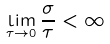<formula> <loc_0><loc_0><loc_500><loc_500>\lim _ { \tau \to 0 } \frac { \sigma } { \tau } < \infty</formula> 